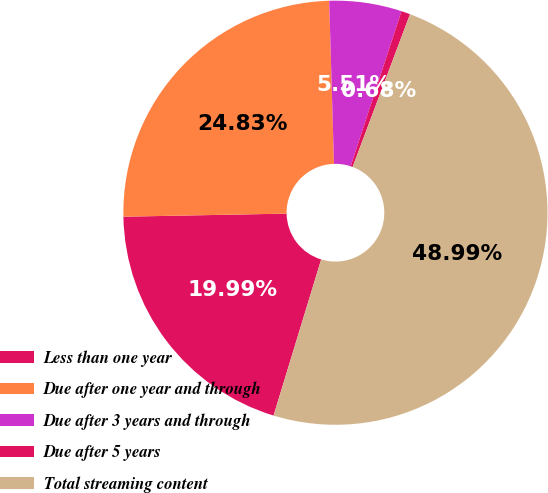<chart> <loc_0><loc_0><loc_500><loc_500><pie_chart><fcel>Less than one year<fcel>Due after one year and through<fcel>Due after 3 years and through<fcel>Due after 5 years<fcel>Total streaming content<nl><fcel>19.99%<fcel>24.83%<fcel>5.51%<fcel>0.68%<fcel>48.99%<nl></chart> 